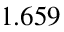<formula> <loc_0><loc_0><loc_500><loc_500>1 . 6 5 9</formula> 